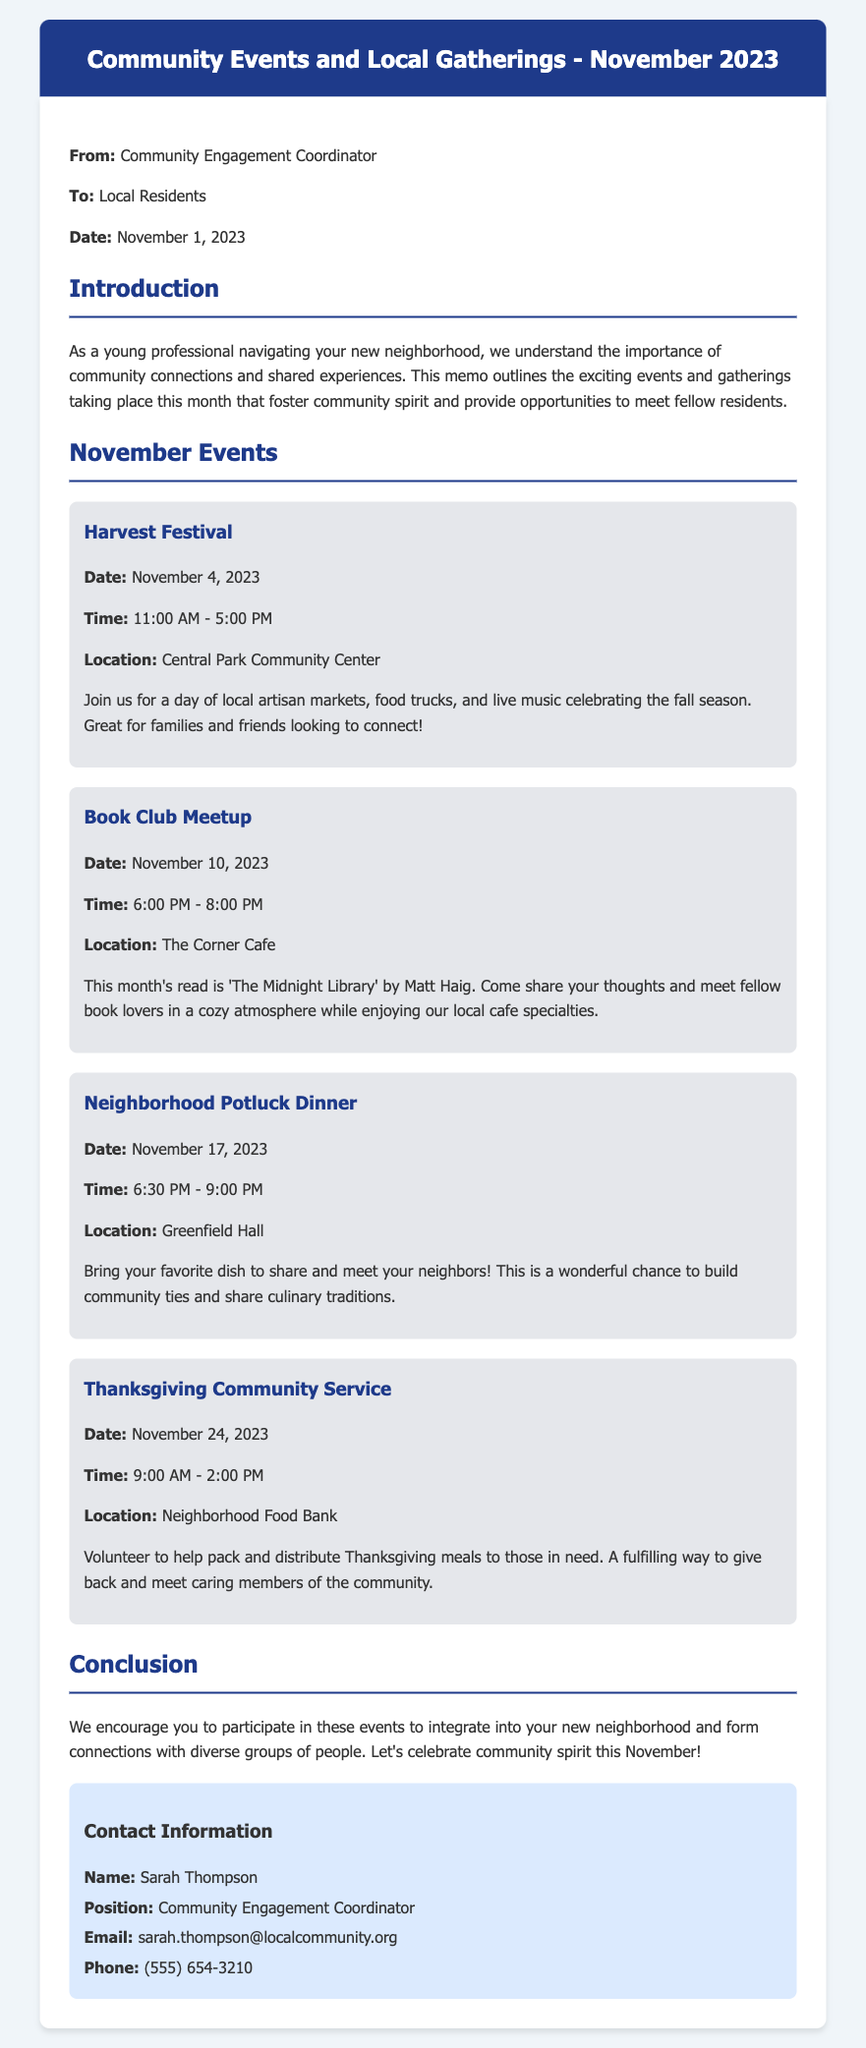What is the first event listed? The first event listed in the memo is the Harvest Festival, which takes place on November 4, 2023.
Answer: Harvest Festival What is the date of the Neighborhood Potluck Dinner? The Neighborhood Potluck Dinner is scheduled for November 17, 2023, as mentioned in the memo.
Answer: November 17, 2023 What time does the Thanksgiving Community Service start? The Thanksgiving Community Service starts at 9:00 AM as stated in the event details.
Answer: 9:00 AM How long is the Book Club Meetup? The Book Club Meetup is for two hours, from 6:00 PM to 8:00 PM, as indicated in the schedule.
Answer: Two hours What is the location of the Harvest Festival? The location of the Harvest Festival is the Central Park Community Center, according to the memo.
Answer: Central Park Community Center Which event involves volunteering? The event that involves volunteering is the Thanksgiving Community Service, where volunteers help pack and distribute meals.
Answer: Thanksgiving Community Service Who is the Community Engagement Coordinator? The memo identifies Sarah Thompson as the Community Engagement Coordinator for the neighborhood.
Answer: Sarah Thompson What should participants bring to the Potluck Dinner? Participants are encouraged to bring their favorite dish to share at the potluck dinner.
Answer: Favorite dish How many community events are mentioned in the memo? Four community events are detailed in the memo for November 2023.
Answer: Four 